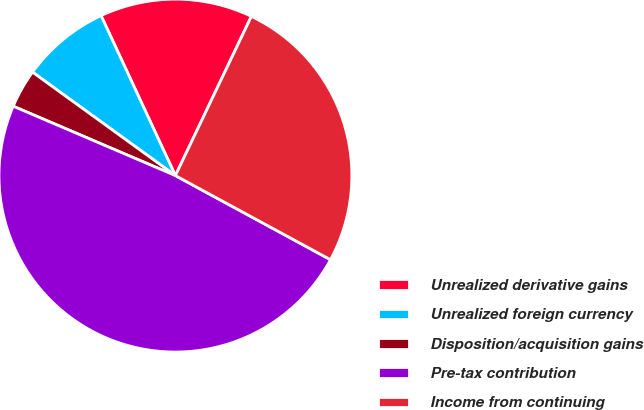Convert chart to OTSL. <chart><loc_0><loc_0><loc_500><loc_500><pie_chart><fcel>Unrealized derivative gains<fcel>Unrealized foreign currency<fcel>Disposition/acquisition gains<fcel>Pre-tax contribution<fcel>Income from continuing<nl><fcel>14.01%<fcel>8.1%<fcel>3.54%<fcel>48.52%<fcel>25.82%<nl></chart> 